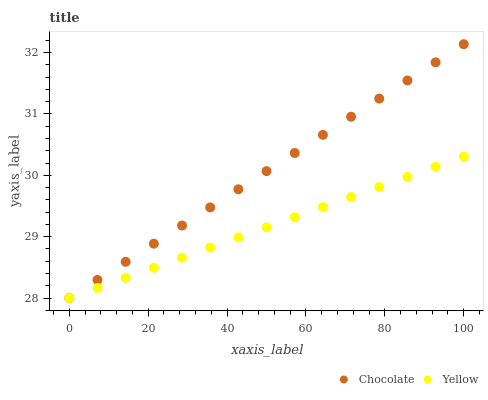Does Yellow have the minimum area under the curve?
Answer yes or no. Yes. Does Chocolate have the maximum area under the curve?
Answer yes or no. Yes. Does Chocolate have the minimum area under the curve?
Answer yes or no. No. Is Chocolate the smoothest?
Answer yes or no. Yes. Is Yellow the roughest?
Answer yes or no. Yes. Is Chocolate the roughest?
Answer yes or no. No. Does Yellow have the lowest value?
Answer yes or no. Yes. Does Chocolate have the highest value?
Answer yes or no. Yes. Does Chocolate intersect Yellow?
Answer yes or no. Yes. Is Chocolate less than Yellow?
Answer yes or no. No. Is Chocolate greater than Yellow?
Answer yes or no. No. 